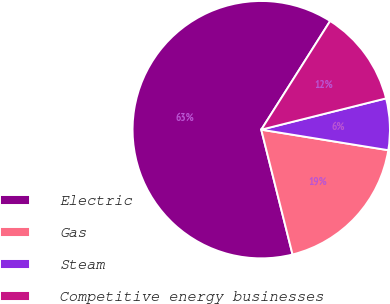<chart> <loc_0><loc_0><loc_500><loc_500><pie_chart><fcel>Electric<fcel>Gas<fcel>Steam<fcel>Competitive energy businesses<nl><fcel>62.9%<fcel>18.54%<fcel>6.46%<fcel>12.1%<nl></chart> 